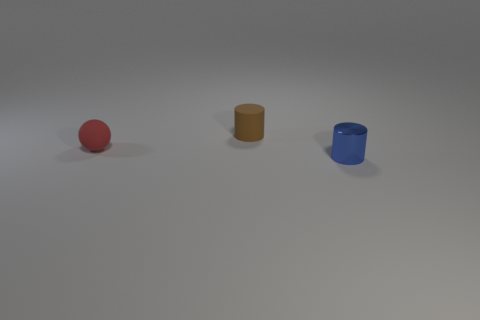Subtract 1 spheres. How many spheres are left? 0 Subtract all blue cylinders. How many cylinders are left? 1 Add 2 large red things. How many objects exist? 5 Subtract all cylinders. How many objects are left? 1 Add 1 rubber balls. How many rubber balls exist? 2 Subtract 0 cyan cylinders. How many objects are left? 3 Subtract all gray cylinders. Subtract all gray cubes. How many cylinders are left? 2 Subtract all small purple matte objects. Subtract all tiny objects. How many objects are left? 0 Add 1 tiny objects. How many tiny objects are left? 4 